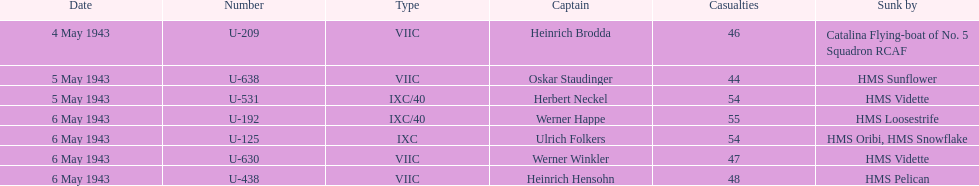Which ship sunk the most u-boats HMS Vidette. 